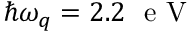Convert formula to latex. <formula><loc_0><loc_0><loc_500><loc_500>\hbar { \omega } _ { q } = 2 . 2 e V</formula> 